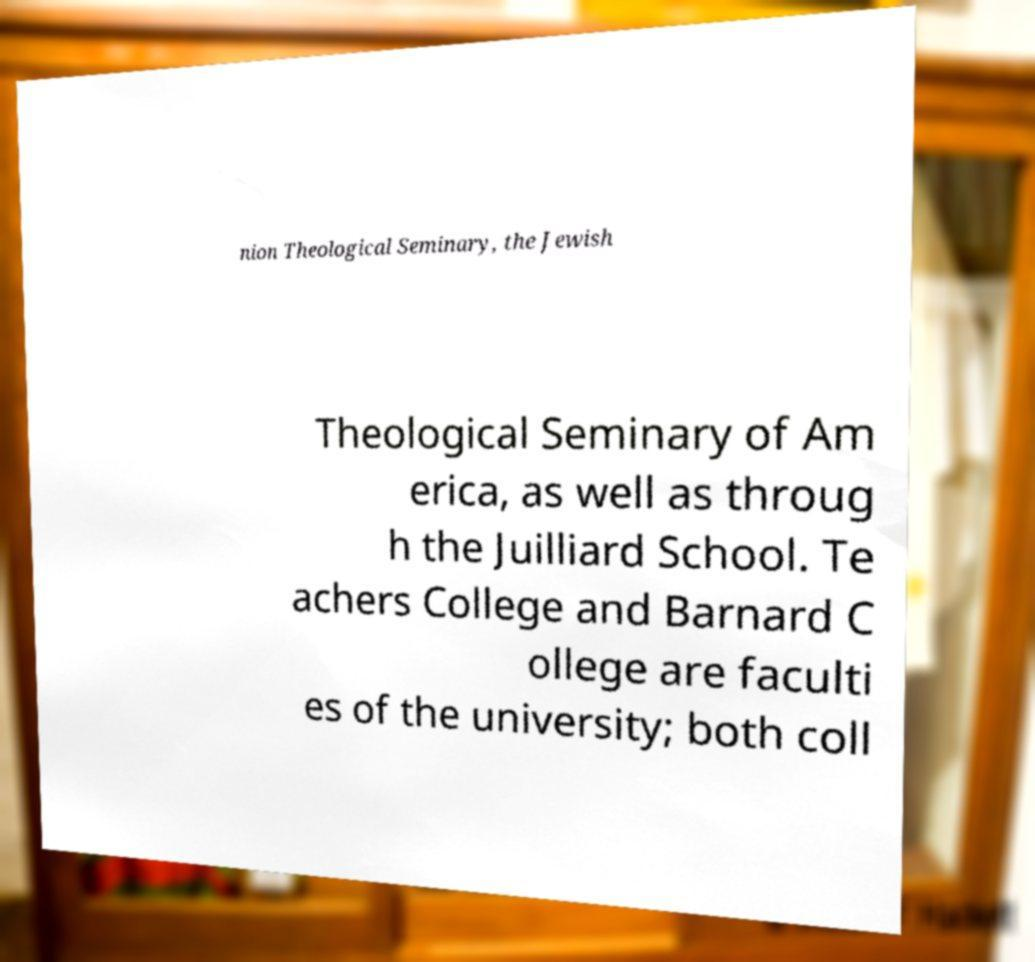Could you extract and type out the text from this image? nion Theological Seminary, the Jewish Theological Seminary of Am erica, as well as throug h the Juilliard School. Te achers College and Barnard C ollege are faculti es of the university; both coll 